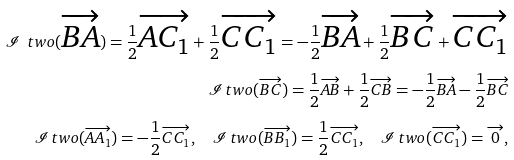Convert formula to latex. <formula><loc_0><loc_0><loc_500><loc_500>\mathcal { I } _ { \ } t w o ( \overrightarrow { B A } ) = \frac { 1 } { 2 } \overrightarrow { A C _ { 1 } } + \frac { 1 } { 2 } \overrightarrow { C C _ { 1 } } = - \frac { 1 } { 2 } \overrightarrow { B A } + \frac { 1 } { 2 } \overrightarrow { B C } + \overrightarrow { C C _ { 1 } } \\ \mathcal { I } _ { \ } t w o ( \overrightarrow { B C } ) = \frac { 1 } { 2 } \overrightarrow { A B } + \frac { 1 } { 2 } \overrightarrow { C B } = - \frac { 1 } { 2 } \overrightarrow { B A } - \frac { 1 } { 2 } \overrightarrow { B C } \\ \mathcal { I } _ { \ } t w o ( \overrightarrow { A A _ { 1 } } ) = - \frac { 1 } { 2 } \overrightarrow { C C _ { 1 } } , \quad \mathcal { I } _ { \ } t w o ( \overrightarrow { B B _ { 1 } } ) = \frac { 1 } { 2 } \overrightarrow { C C _ { 1 } } , \quad \mathcal { I } _ { \ } t w o ( \overrightarrow { C C _ { 1 } } ) = \overrightarrow { 0 } ,</formula> 